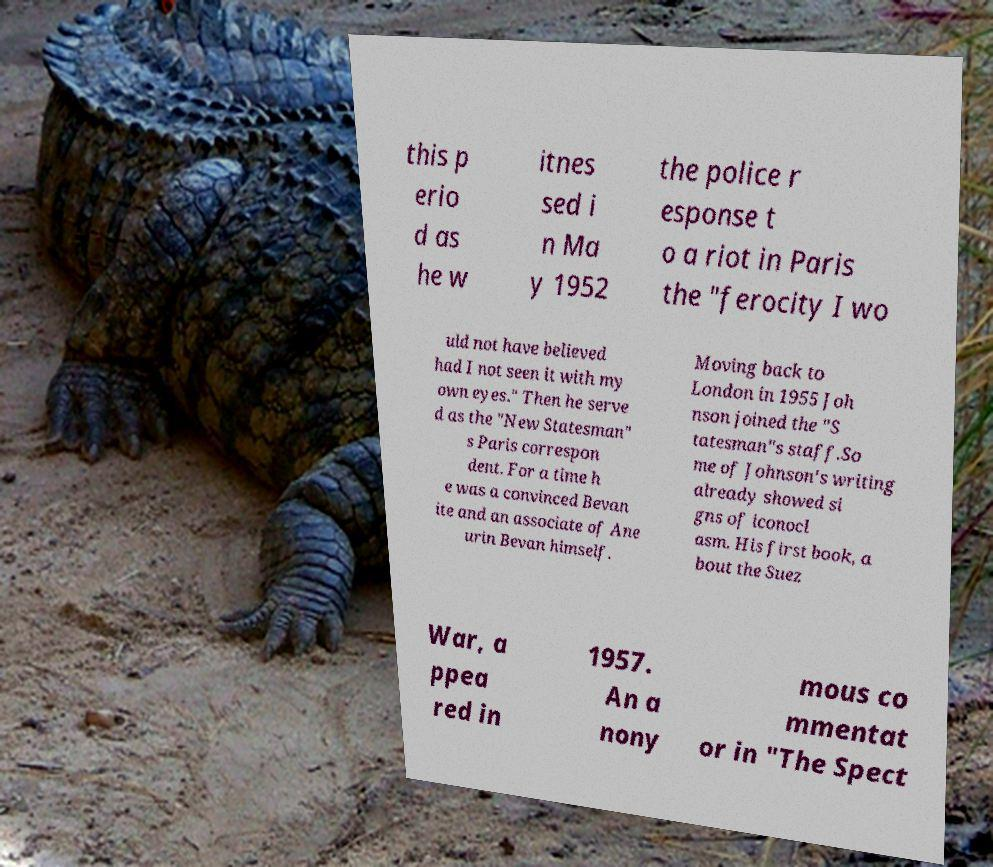Could you extract and type out the text from this image? this p erio d as he w itnes sed i n Ma y 1952 the police r esponse t o a riot in Paris the "ferocity I wo uld not have believed had I not seen it with my own eyes." Then he serve d as the "New Statesman" s Paris correspon dent. For a time h e was a convinced Bevan ite and an associate of Ane urin Bevan himself. Moving back to London in 1955 Joh nson joined the "S tatesman"s staff.So me of Johnson's writing already showed si gns of iconocl asm. His first book, a bout the Suez War, a ppea red in 1957. An a nony mous co mmentat or in "The Spect 